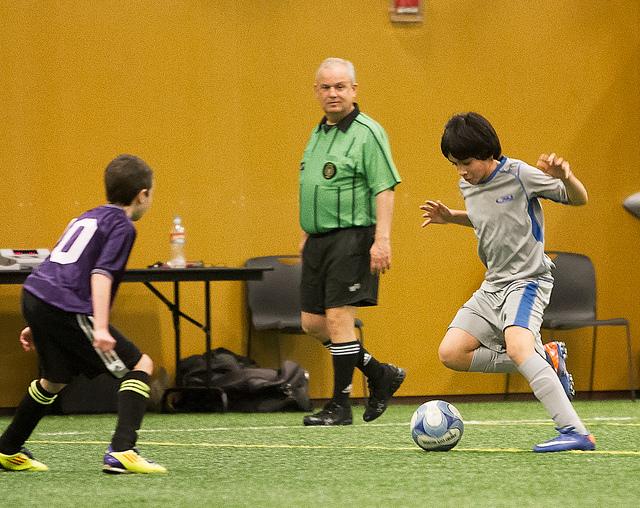Where is the water bottle?
Write a very short answer. On table. What sport are the kids playing?
Be succinct. Soccer. What color is the ref's shirt?
Write a very short answer. Green. 